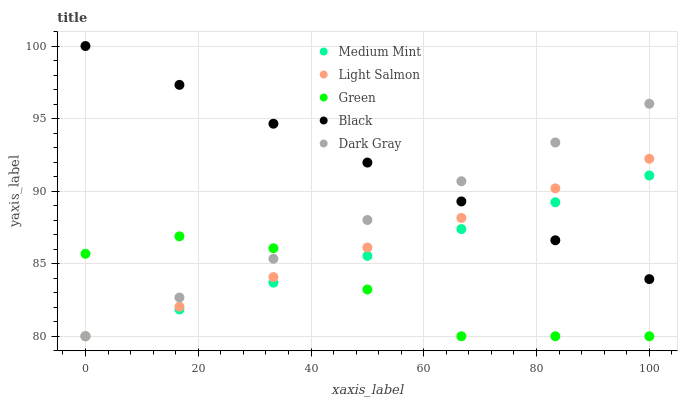Does Green have the minimum area under the curve?
Answer yes or no. Yes. Does Black have the maximum area under the curve?
Answer yes or no. Yes. Does Light Salmon have the minimum area under the curve?
Answer yes or no. No. Does Light Salmon have the maximum area under the curve?
Answer yes or no. No. Is Medium Mint the smoothest?
Answer yes or no. Yes. Is Green the roughest?
Answer yes or no. Yes. Is Black the smoothest?
Answer yes or no. No. Is Black the roughest?
Answer yes or no. No. Does Medium Mint have the lowest value?
Answer yes or no. Yes. Does Black have the lowest value?
Answer yes or no. No. Does Black have the highest value?
Answer yes or no. Yes. Does Light Salmon have the highest value?
Answer yes or no. No. Is Green less than Black?
Answer yes or no. Yes. Is Black greater than Green?
Answer yes or no. Yes. Does Dark Gray intersect Green?
Answer yes or no. Yes. Is Dark Gray less than Green?
Answer yes or no. No. Is Dark Gray greater than Green?
Answer yes or no. No. Does Green intersect Black?
Answer yes or no. No. 